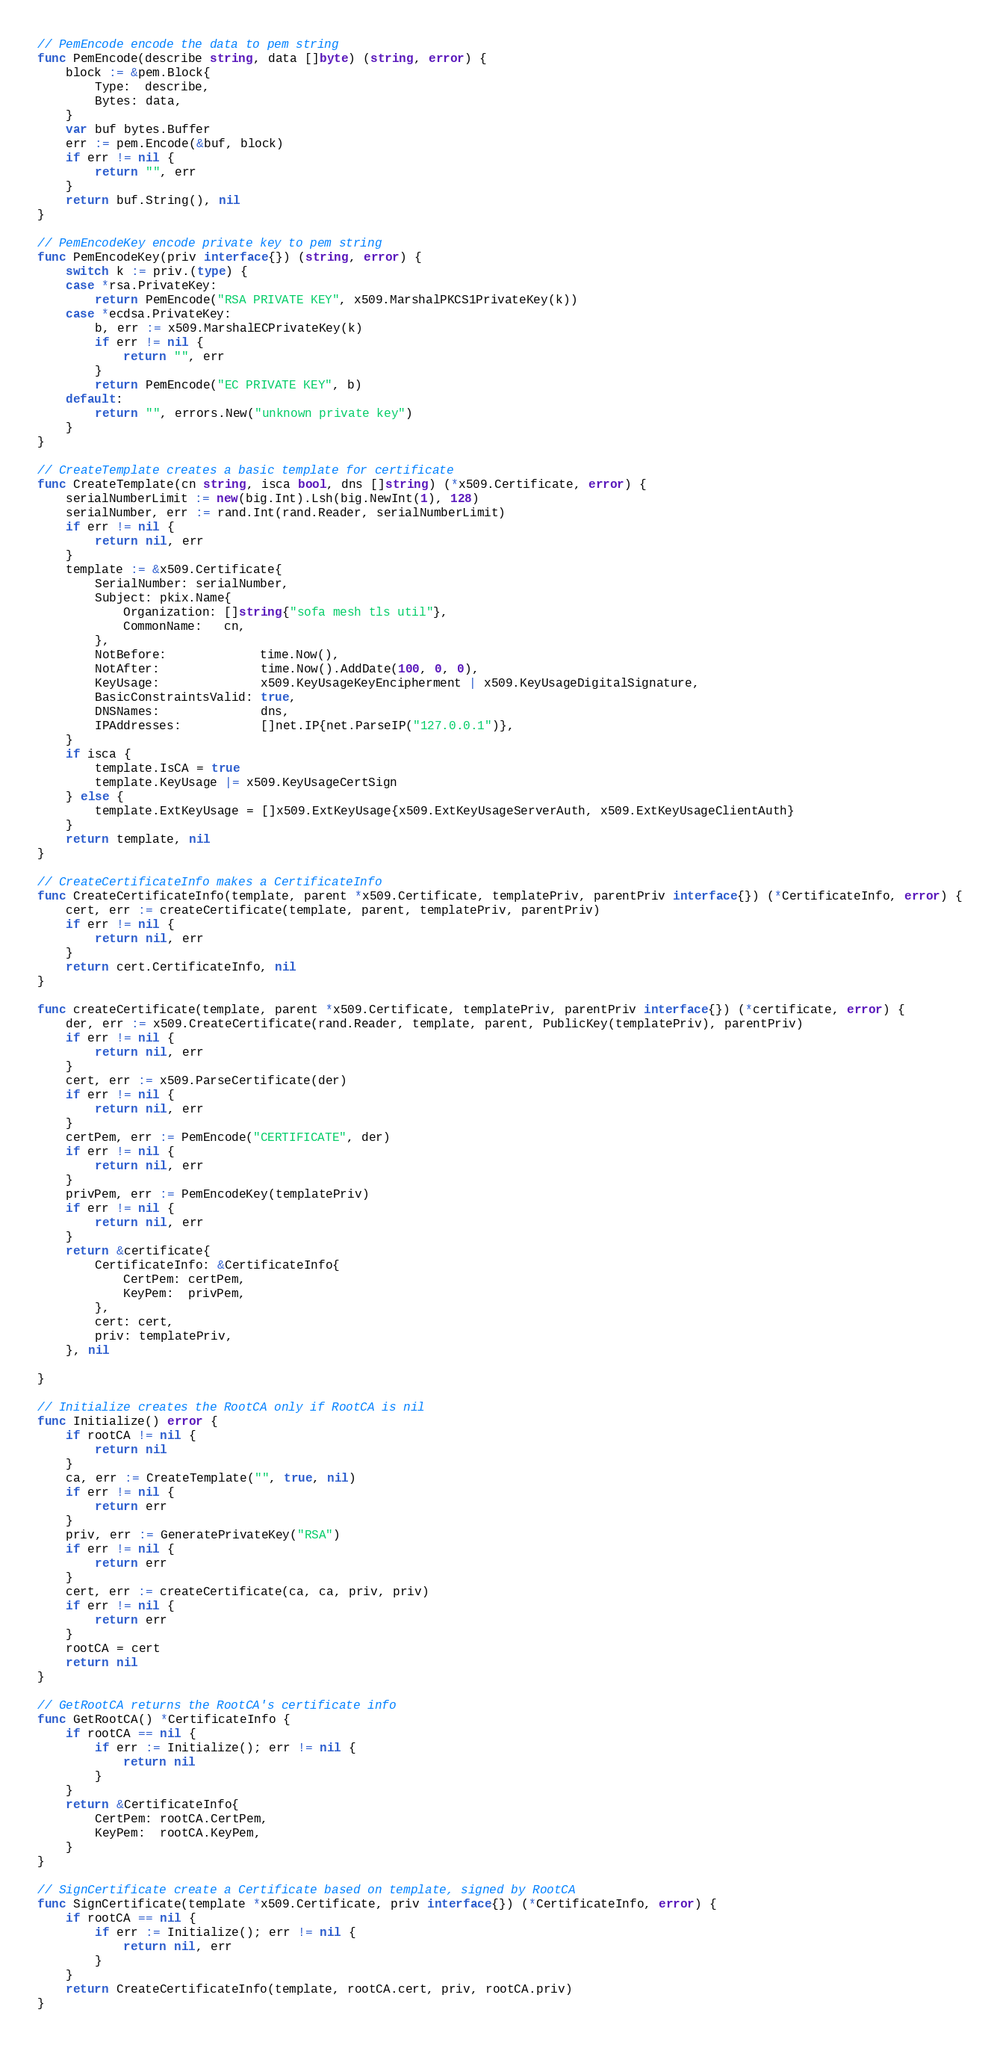<code> <loc_0><loc_0><loc_500><loc_500><_Go_>
// PemEncode encode the data to pem string
func PemEncode(describe string, data []byte) (string, error) {
	block := &pem.Block{
		Type:  describe,
		Bytes: data,
	}
	var buf bytes.Buffer
	err := pem.Encode(&buf, block)
	if err != nil {
		return "", err
	}
	return buf.String(), nil
}

// PemEncodeKey encode private key to pem string
func PemEncodeKey(priv interface{}) (string, error) {
	switch k := priv.(type) {
	case *rsa.PrivateKey:
		return PemEncode("RSA PRIVATE KEY", x509.MarshalPKCS1PrivateKey(k))
	case *ecdsa.PrivateKey:
		b, err := x509.MarshalECPrivateKey(k)
		if err != nil {
			return "", err
		}
		return PemEncode("EC PRIVATE KEY", b)
	default:
		return "", errors.New("unknown private key")
	}
}

// CreateTemplate creates a basic template for certificate
func CreateTemplate(cn string, isca bool, dns []string) (*x509.Certificate, error) {
	serialNumberLimit := new(big.Int).Lsh(big.NewInt(1), 128)
	serialNumber, err := rand.Int(rand.Reader, serialNumberLimit)
	if err != nil {
		return nil, err
	}
	template := &x509.Certificate{
		SerialNumber: serialNumber,
		Subject: pkix.Name{
			Organization: []string{"sofa mesh tls util"},
			CommonName:   cn,
		},
		NotBefore:             time.Now(),
		NotAfter:              time.Now().AddDate(100, 0, 0),
		KeyUsage:              x509.KeyUsageKeyEncipherment | x509.KeyUsageDigitalSignature,
		BasicConstraintsValid: true,
		DNSNames:              dns,
		IPAddresses:           []net.IP{net.ParseIP("127.0.0.1")},
	}
	if isca {
		template.IsCA = true
		template.KeyUsage |= x509.KeyUsageCertSign
	} else {
		template.ExtKeyUsage = []x509.ExtKeyUsage{x509.ExtKeyUsageServerAuth, x509.ExtKeyUsageClientAuth}
	}
	return template, nil
}

// CreateCertificateInfo makes a CertificateInfo
func CreateCertificateInfo(template, parent *x509.Certificate, templatePriv, parentPriv interface{}) (*CertificateInfo, error) {
	cert, err := createCertificate(template, parent, templatePriv, parentPriv)
	if err != nil {
		return nil, err
	}
	return cert.CertificateInfo, nil
}

func createCertificate(template, parent *x509.Certificate, templatePriv, parentPriv interface{}) (*certificate, error) {
	der, err := x509.CreateCertificate(rand.Reader, template, parent, PublicKey(templatePriv), parentPriv)
	if err != nil {
		return nil, err
	}
	cert, err := x509.ParseCertificate(der)
	if err != nil {
		return nil, err
	}
	certPem, err := PemEncode("CERTIFICATE", der)
	if err != nil {
		return nil, err
	}
	privPem, err := PemEncodeKey(templatePriv)
	if err != nil {
		return nil, err
	}
	return &certificate{
		CertificateInfo: &CertificateInfo{
			CertPem: certPem,
			KeyPem:  privPem,
		},
		cert: cert,
		priv: templatePriv,
	}, nil

}

// Initialize creates the RootCA only if RootCA is nil
func Initialize() error {
	if rootCA != nil {
		return nil
	}
	ca, err := CreateTemplate("", true, nil)
	if err != nil {
		return err
	}
	priv, err := GeneratePrivateKey("RSA")
	if err != nil {
		return err
	}
	cert, err := createCertificate(ca, ca, priv, priv)
	if err != nil {
		return err
	}
	rootCA = cert
	return nil
}

// GetRootCA returns the RootCA's certificate info
func GetRootCA() *CertificateInfo {
	if rootCA == nil {
		if err := Initialize(); err != nil {
			return nil
		}
	}
	return &CertificateInfo{
		CertPem: rootCA.CertPem,
		KeyPem:  rootCA.KeyPem,
	}
}

// SignCertificate create a Certificate based on template, signed by RootCA
func SignCertificate(template *x509.Certificate, priv interface{}) (*CertificateInfo, error) {
	if rootCA == nil {
		if err := Initialize(); err != nil {
			return nil, err
		}
	}
	return CreateCertificateInfo(template, rootCA.cert, priv, rootCA.priv)
}
</code> 